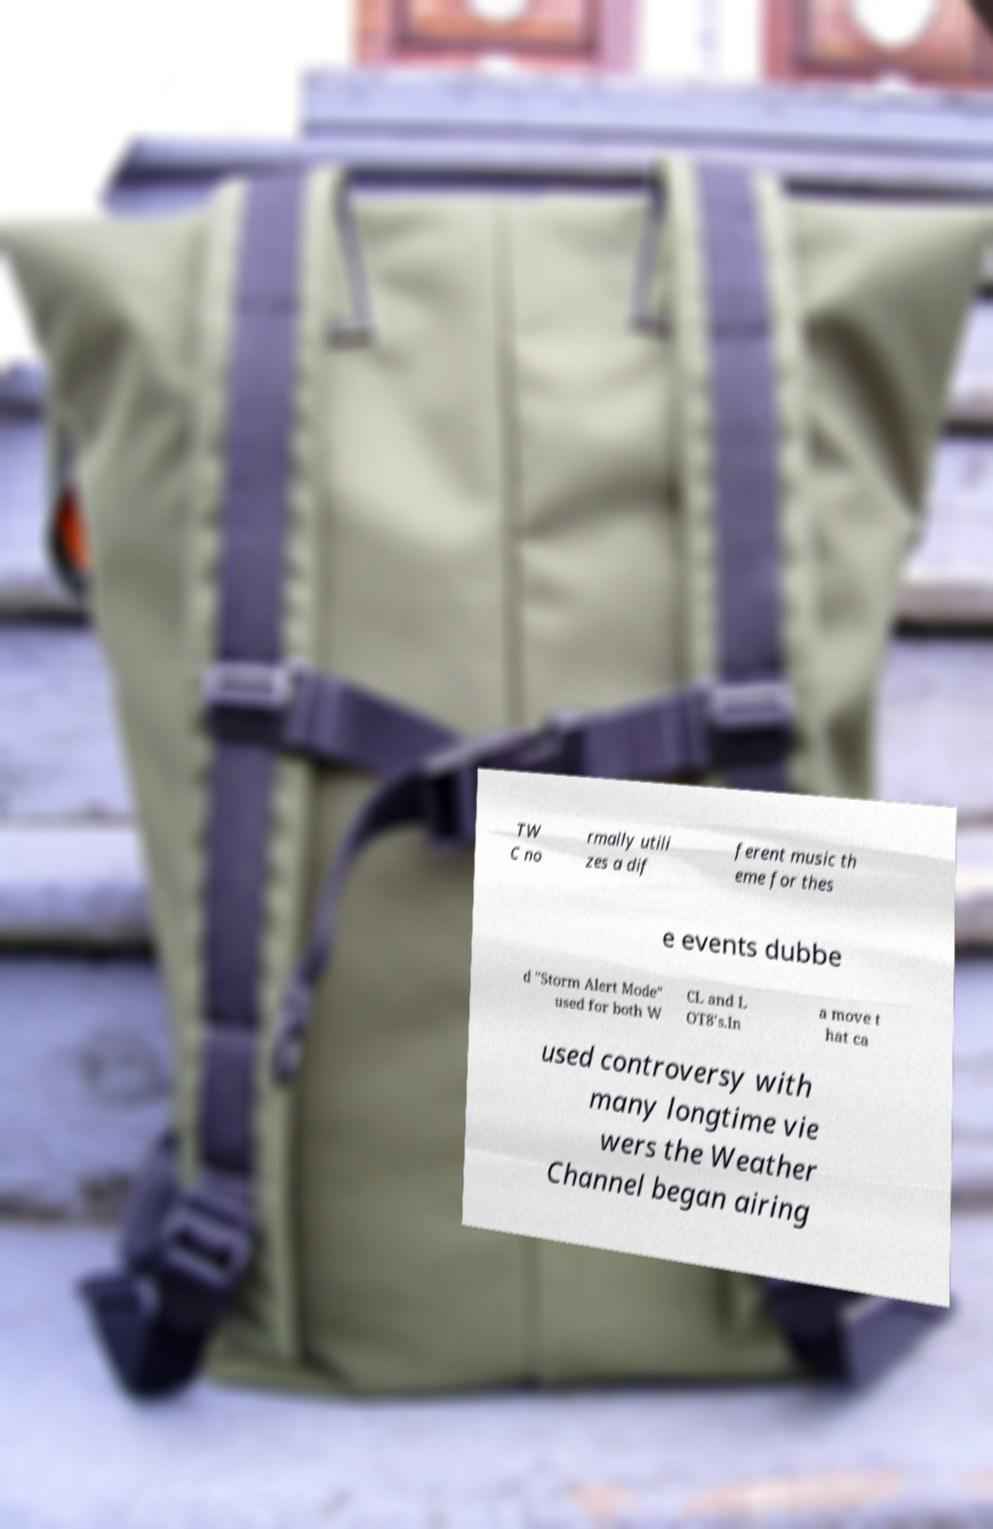I need the written content from this picture converted into text. Can you do that? TW C no rmally utili zes a dif ferent music th eme for thes e events dubbe d "Storm Alert Mode" used for both W CL and L OT8's.In a move t hat ca used controversy with many longtime vie wers the Weather Channel began airing 